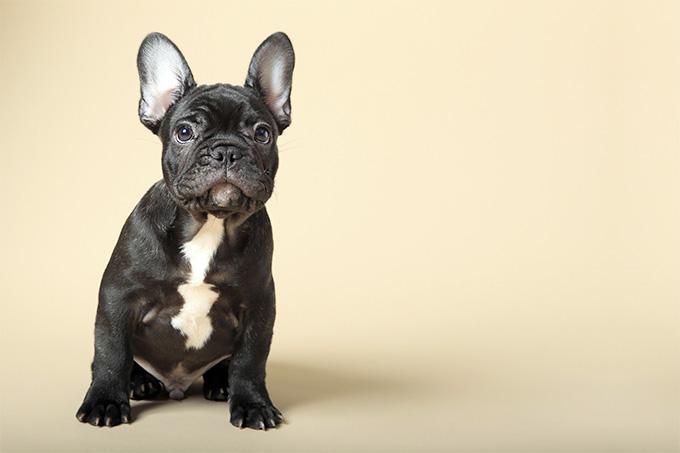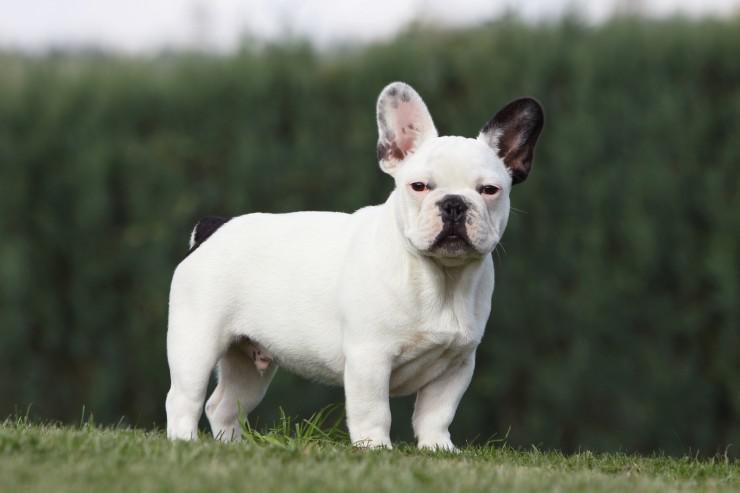The first image is the image on the left, the second image is the image on the right. Given the left and right images, does the statement "One image shows a black and white dog on a field scattered with wild flowers." hold true? Answer yes or no. No. 